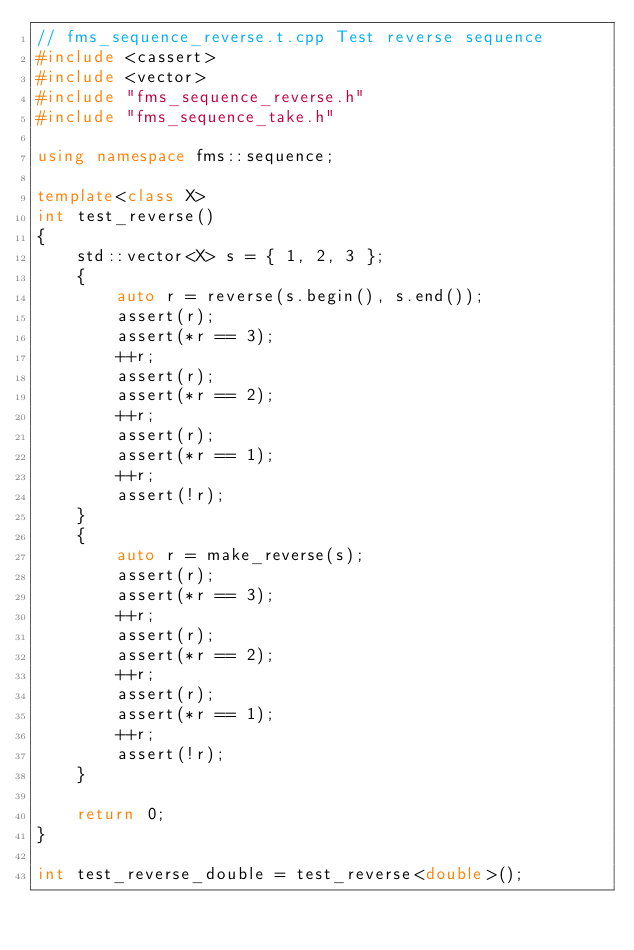<code> <loc_0><loc_0><loc_500><loc_500><_C++_>// fms_sequence_reverse.t.cpp Test reverse sequence
#include <cassert>
#include <vector>
#include "fms_sequence_reverse.h"
#include "fms_sequence_take.h"

using namespace fms::sequence;

template<class X>
int test_reverse()
{
    std::vector<X> s = { 1, 2, 3 };
    {
        auto r = reverse(s.begin(), s.end());
        assert(r);
        assert(*r == 3);
        ++r;
        assert(r);
        assert(*r == 2);
        ++r;
        assert(r);
        assert(*r == 1);
        ++r;
        assert(!r);
    }
    {
        auto r = make_reverse(s);
        assert(r);
        assert(*r == 3);
        ++r;
        assert(r);
        assert(*r == 2);
        ++r;
        assert(r);
        assert(*r == 1);
        ++r;
        assert(!r);
    }

    return 0;
}

int test_reverse_double = test_reverse<double>();</code> 